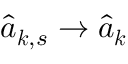Convert formula to latex. <formula><loc_0><loc_0><loc_500><loc_500>\hat { a } _ { { \boldsymbol k } , s } \rightarrow \hat { a } _ { \boldsymbol k }</formula> 